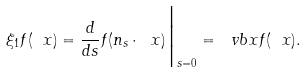<formula> <loc_0><loc_0><loc_500><loc_500>\xi _ { 1 } f ( \ x ) = \frac { d } { d s } f ( n _ { s } \cdot \ x ) \Big | _ { s = 0 } = \ v b x f ( \ x ) .</formula> 